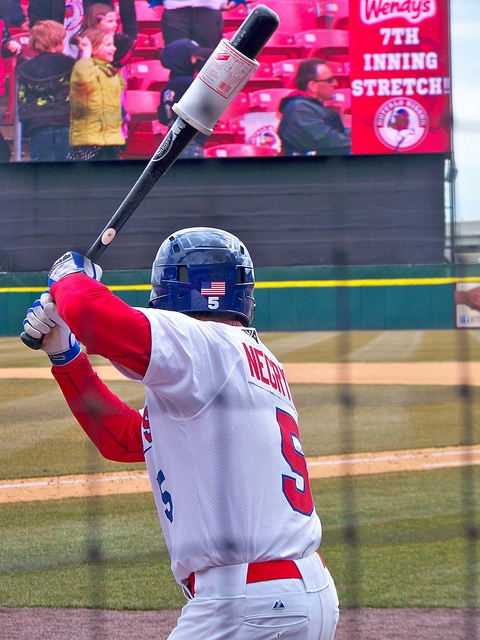Describe the objects in this image and their specific colors. I can see people in purple, darkgray, lavender, brown, and gray tones and baseball bat in purple, black, lavender, darkgray, and gray tones in this image. 